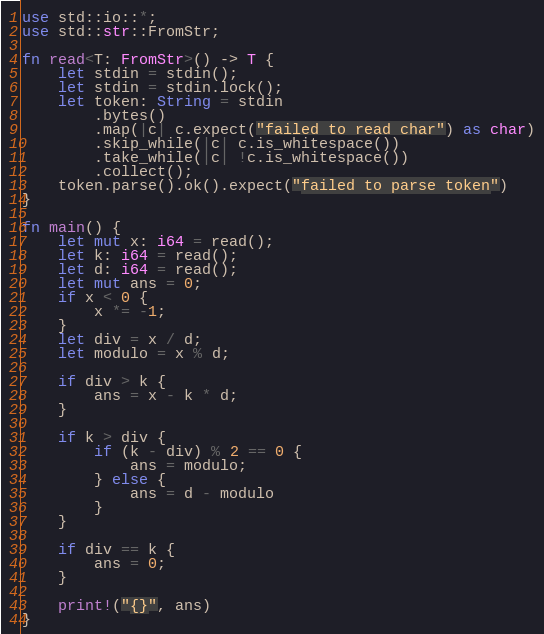<code> <loc_0><loc_0><loc_500><loc_500><_Rust_>use std::io::*;
use std::str::FromStr;

fn read<T: FromStr>() -> T {
    let stdin = stdin();
    let stdin = stdin.lock();
    let token: String = stdin
        .bytes()
        .map(|c| c.expect("failed to read char") as char)
        .skip_while(|c| c.is_whitespace())
        .take_while(|c| !c.is_whitespace())
        .collect();
    token.parse().ok().expect("failed to parse token")
}

fn main() {
    let mut x: i64 = read();
    let k: i64 = read();
    let d: i64 = read();
    let mut ans = 0;
    if x < 0 {
        x *= -1;
    }
    let div = x / d;
    let modulo = x % d;

    if div > k {
        ans = x - k * d;
    }

    if k > div {
        if (k - div) % 2 == 0 {
            ans = modulo;
        } else {
            ans = d - modulo
        }
    }

    if div == k {
        ans = 0;
    }

    print!("{}", ans)
}
</code> 